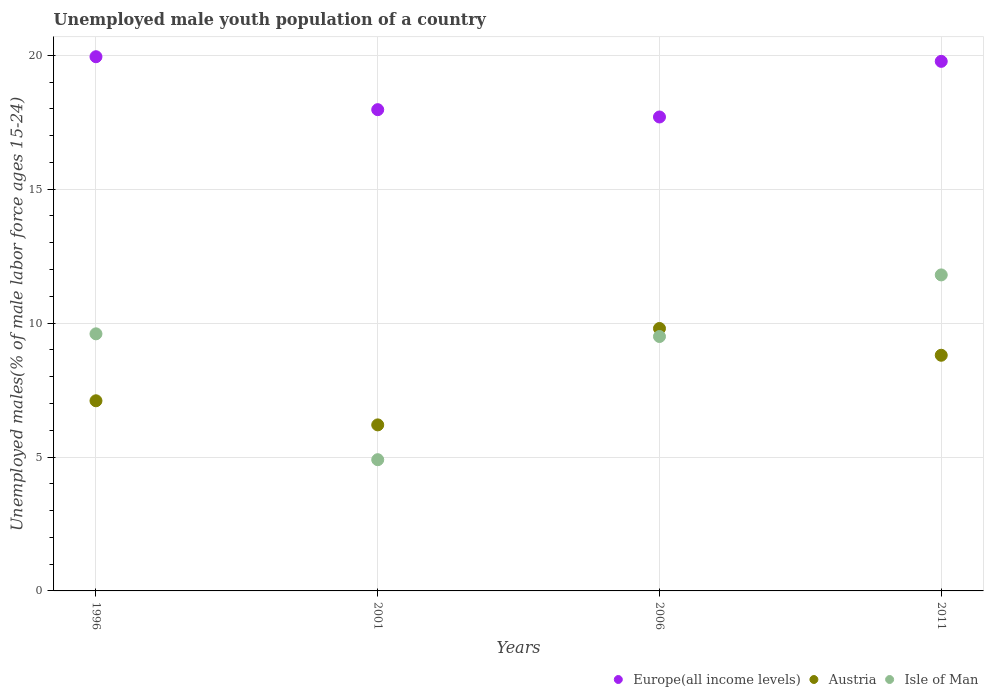How many different coloured dotlines are there?
Keep it short and to the point. 3. Is the number of dotlines equal to the number of legend labels?
Your answer should be very brief. Yes. What is the percentage of unemployed male youth population in Isle of Man in 1996?
Your response must be concise. 9.6. Across all years, what is the maximum percentage of unemployed male youth population in Austria?
Provide a succinct answer. 9.8. Across all years, what is the minimum percentage of unemployed male youth population in Europe(all income levels)?
Keep it short and to the point. 17.7. In which year was the percentage of unemployed male youth population in Isle of Man maximum?
Provide a short and direct response. 2011. In which year was the percentage of unemployed male youth population in Europe(all income levels) minimum?
Your answer should be compact. 2006. What is the total percentage of unemployed male youth population in Austria in the graph?
Make the answer very short. 31.9. What is the difference between the percentage of unemployed male youth population in Isle of Man in 1996 and that in 2001?
Your answer should be very brief. 4.7. What is the difference between the percentage of unemployed male youth population in Isle of Man in 2006 and the percentage of unemployed male youth population in Austria in 2011?
Keep it short and to the point. 0.7. What is the average percentage of unemployed male youth population in Austria per year?
Make the answer very short. 7.98. In the year 1996, what is the difference between the percentage of unemployed male youth population in Isle of Man and percentage of unemployed male youth population in Austria?
Give a very brief answer. 2.5. What is the ratio of the percentage of unemployed male youth population in Austria in 1996 to that in 2006?
Offer a very short reply. 0.72. Is the difference between the percentage of unemployed male youth population in Isle of Man in 1996 and 2006 greater than the difference between the percentage of unemployed male youth population in Austria in 1996 and 2006?
Give a very brief answer. Yes. What is the difference between the highest and the lowest percentage of unemployed male youth population in Austria?
Your answer should be very brief. 3.6. Is it the case that in every year, the sum of the percentage of unemployed male youth population in Isle of Man and percentage of unemployed male youth population in Europe(all income levels)  is greater than the percentage of unemployed male youth population in Austria?
Make the answer very short. Yes. Is the percentage of unemployed male youth population in Isle of Man strictly less than the percentage of unemployed male youth population in Europe(all income levels) over the years?
Provide a short and direct response. Yes. How many dotlines are there?
Your answer should be very brief. 3. How many years are there in the graph?
Provide a short and direct response. 4. Are the values on the major ticks of Y-axis written in scientific E-notation?
Give a very brief answer. No. What is the title of the graph?
Your answer should be compact. Unemployed male youth population of a country. Does "Bosnia and Herzegovina" appear as one of the legend labels in the graph?
Offer a very short reply. No. What is the label or title of the X-axis?
Your answer should be compact. Years. What is the label or title of the Y-axis?
Your answer should be very brief. Unemployed males(% of male labor force ages 15-24). What is the Unemployed males(% of male labor force ages 15-24) of Europe(all income levels) in 1996?
Provide a succinct answer. 19.95. What is the Unemployed males(% of male labor force ages 15-24) in Austria in 1996?
Your answer should be compact. 7.1. What is the Unemployed males(% of male labor force ages 15-24) of Isle of Man in 1996?
Ensure brevity in your answer.  9.6. What is the Unemployed males(% of male labor force ages 15-24) in Europe(all income levels) in 2001?
Make the answer very short. 17.97. What is the Unemployed males(% of male labor force ages 15-24) of Austria in 2001?
Ensure brevity in your answer.  6.2. What is the Unemployed males(% of male labor force ages 15-24) of Isle of Man in 2001?
Give a very brief answer. 4.9. What is the Unemployed males(% of male labor force ages 15-24) of Europe(all income levels) in 2006?
Your answer should be very brief. 17.7. What is the Unemployed males(% of male labor force ages 15-24) of Austria in 2006?
Give a very brief answer. 9.8. What is the Unemployed males(% of male labor force ages 15-24) in Isle of Man in 2006?
Provide a short and direct response. 9.5. What is the Unemployed males(% of male labor force ages 15-24) of Europe(all income levels) in 2011?
Ensure brevity in your answer.  19.77. What is the Unemployed males(% of male labor force ages 15-24) of Austria in 2011?
Keep it short and to the point. 8.8. What is the Unemployed males(% of male labor force ages 15-24) in Isle of Man in 2011?
Your response must be concise. 11.8. Across all years, what is the maximum Unemployed males(% of male labor force ages 15-24) in Europe(all income levels)?
Give a very brief answer. 19.95. Across all years, what is the maximum Unemployed males(% of male labor force ages 15-24) in Austria?
Keep it short and to the point. 9.8. Across all years, what is the maximum Unemployed males(% of male labor force ages 15-24) of Isle of Man?
Ensure brevity in your answer.  11.8. Across all years, what is the minimum Unemployed males(% of male labor force ages 15-24) of Europe(all income levels)?
Your answer should be compact. 17.7. Across all years, what is the minimum Unemployed males(% of male labor force ages 15-24) of Austria?
Your response must be concise. 6.2. Across all years, what is the minimum Unemployed males(% of male labor force ages 15-24) in Isle of Man?
Give a very brief answer. 4.9. What is the total Unemployed males(% of male labor force ages 15-24) of Europe(all income levels) in the graph?
Give a very brief answer. 75.39. What is the total Unemployed males(% of male labor force ages 15-24) of Austria in the graph?
Keep it short and to the point. 31.9. What is the total Unemployed males(% of male labor force ages 15-24) of Isle of Man in the graph?
Provide a short and direct response. 35.8. What is the difference between the Unemployed males(% of male labor force ages 15-24) of Europe(all income levels) in 1996 and that in 2001?
Provide a succinct answer. 1.98. What is the difference between the Unemployed males(% of male labor force ages 15-24) of Isle of Man in 1996 and that in 2001?
Your answer should be very brief. 4.7. What is the difference between the Unemployed males(% of male labor force ages 15-24) of Europe(all income levels) in 1996 and that in 2006?
Give a very brief answer. 2.25. What is the difference between the Unemployed males(% of male labor force ages 15-24) in Isle of Man in 1996 and that in 2006?
Make the answer very short. 0.1. What is the difference between the Unemployed males(% of male labor force ages 15-24) of Europe(all income levels) in 1996 and that in 2011?
Offer a very short reply. 0.17. What is the difference between the Unemployed males(% of male labor force ages 15-24) of Austria in 1996 and that in 2011?
Your response must be concise. -1.7. What is the difference between the Unemployed males(% of male labor force ages 15-24) in Europe(all income levels) in 2001 and that in 2006?
Your answer should be very brief. 0.27. What is the difference between the Unemployed males(% of male labor force ages 15-24) in Austria in 2001 and that in 2006?
Make the answer very short. -3.6. What is the difference between the Unemployed males(% of male labor force ages 15-24) in Isle of Man in 2001 and that in 2006?
Your response must be concise. -4.6. What is the difference between the Unemployed males(% of male labor force ages 15-24) of Europe(all income levels) in 2001 and that in 2011?
Offer a very short reply. -1.8. What is the difference between the Unemployed males(% of male labor force ages 15-24) of Austria in 2001 and that in 2011?
Offer a terse response. -2.6. What is the difference between the Unemployed males(% of male labor force ages 15-24) of Isle of Man in 2001 and that in 2011?
Give a very brief answer. -6.9. What is the difference between the Unemployed males(% of male labor force ages 15-24) of Europe(all income levels) in 2006 and that in 2011?
Ensure brevity in your answer.  -2.08. What is the difference between the Unemployed males(% of male labor force ages 15-24) of Austria in 2006 and that in 2011?
Make the answer very short. 1. What is the difference between the Unemployed males(% of male labor force ages 15-24) in Europe(all income levels) in 1996 and the Unemployed males(% of male labor force ages 15-24) in Austria in 2001?
Give a very brief answer. 13.75. What is the difference between the Unemployed males(% of male labor force ages 15-24) of Europe(all income levels) in 1996 and the Unemployed males(% of male labor force ages 15-24) of Isle of Man in 2001?
Provide a succinct answer. 15.05. What is the difference between the Unemployed males(% of male labor force ages 15-24) of Austria in 1996 and the Unemployed males(% of male labor force ages 15-24) of Isle of Man in 2001?
Offer a terse response. 2.2. What is the difference between the Unemployed males(% of male labor force ages 15-24) in Europe(all income levels) in 1996 and the Unemployed males(% of male labor force ages 15-24) in Austria in 2006?
Keep it short and to the point. 10.15. What is the difference between the Unemployed males(% of male labor force ages 15-24) of Europe(all income levels) in 1996 and the Unemployed males(% of male labor force ages 15-24) of Isle of Man in 2006?
Ensure brevity in your answer.  10.45. What is the difference between the Unemployed males(% of male labor force ages 15-24) in Austria in 1996 and the Unemployed males(% of male labor force ages 15-24) in Isle of Man in 2006?
Keep it short and to the point. -2.4. What is the difference between the Unemployed males(% of male labor force ages 15-24) of Europe(all income levels) in 1996 and the Unemployed males(% of male labor force ages 15-24) of Austria in 2011?
Your answer should be compact. 11.15. What is the difference between the Unemployed males(% of male labor force ages 15-24) of Europe(all income levels) in 1996 and the Unemployed males(% of male labor force ages 15-24) of Isle of Man in 2011?
Make the answer very short. 8.15. What is the difference between the Unemployed males(% of male labor force ages 15-24) of Europe(all income levels) in 2001 and the Unemployed males(% of male labor force ages 15-24) of Austria in 2006?
Make the answer very short. 8.17. What is the difference between the Unemployed males(% of male labor force ages 15-24) of Europe(all income levels) in 2001 and the Unemployed males(% of male labor force ages 15-24) of Isle of Man in 2006?
Give a very brief answer. 8.47. What is the difference between the Unemployed males(% of male labor force ages 15-24) of Europe(all income levels) in 2001 and the Unemployed males(% of male labor force ages 15-24) of Austria in 2011?
Your response must be concise. 9.17. What is the difference between the Unemployed males(% of male labor force ages 15-24) of Europe(all income levels) in 2001 and the Unemployed males(% of male labor force ages 15-24) of Isle of Man in 2011?
Make the answer very short. 6.17. What is the difference between the Unemployed males(% of male labor force ages 15-24) of Austria in 2001 and the Unemployed males(% of male labor force ages 15-24) of Isle of Man in 2011?
Your response must be concise. -5.6. What is the difference between the Unemployed males(% of male labor force ages 15-24) of Europe(all income levels) in 2006 and the Unemployed males(% of male labor force ages 15-24) of Austria in 2011?
Offer a very short reply. 8.9. What is the difference between the Unemployed males(% of male labor force ages 15-24) of Europe(all income levels) in 2006 and the Unemployed males(% of male labor force ages 15-24) of Isle of Man in 2011?
Provide a succinct answer. 5.9. What is the average Unemployed males(% of male labor force ages 15-24) of Europe(all income levels) per year?
Provide a succinct answer. 18.85. What is the average Unemployed males(% of male labor force ages 15-24) in Austria per year?
Your answer should be compact. 7.97. What is the average Unemployed males(% of male labor force ages 15-24) of Isle of Man per year?
Offer a terse response. 8.95. In the year 1996, what is the difference between the Unemployed males(% of male labor force ages 15-24) of Europe(all income levels) and Unemployed males(% of male labor force ages 15-24) of Austria?
Ensure brevity in your answer.  12.85. In the year 1996, what is the difference between the Unemployed males(% of male labor force ages 15-24) of Europe(all income levels) and Unemployed males(% of male labor force ages 15-24) of Isle of Man?
Keep it short and to the point. 10.35. In the year 2001, what is the difference between the Unemployed males(% of male labor force ages 15-24) of Europe(all income levels) and Unemployed males(% of male labor force ages 15-24) of Austria?
Ensure brevity in your answer.  11.77. In the year 2001, what is the difference between the Unemployed males(% of male labor force ages 15-24) in Europe(all income levels) and Unemployed males(% of male labor force ages 15-24) in Isle of Man?
Provide a short and direct response. 13.07. In the year 2006, what is the difference between the Unemployed males(% of male labor force ages 15-24) in Europe(all income levels) and Unemployed males(% of male labor force ages 15-24) in Austria?
Offer a very short reply. 7.9. In the year 2006, what is the difference between the Unemployed males(% of male labor force ages 15-24) of Europe(all income levels) and Unemployed males(% of male labor force ages 15-24) of Isle of Man?
Offer a terse response. 8.2. In the year 2006, what is the difference between the Unemployed males(% of male labor force ages 15-24) in Austria and Unemployed males(% of male labor force ages 15-24) in Isle of Man?
Offer a terse response. 0.3. In the year 2011, what is the difference between the Unemployed males(% of male labor force ages 15-24) of Europe(all income levels) and Unemployed males(% of male labor force ages 15-24) of Austria?
Provide a short and direct response. 10.97. In the year 2011, what is the difference between the Unemployed males(% of male labor force ages 15-24) of Europe(all income levels) and Unemployed males(% of male labor force ages 15-24) of Isle of Man?
Your answer should be compact. 7.97. What is the ratio of the Unemployed males(% of male labor force ages 15-24) of Europe(all income levels) in 1996 to that in 2001?
Offer a terse response. 1.11. What is the ratio of the Unemployed males(% of male labor force ages 15-24) of Austria in 1996 to that in 2001?
Offer a very short reply. 1.15. What is the ratio of the Unemployed males(% of male labor force ages 15-24) of Isle of Man in 1996 to that in 2001?
Make the answer very short. 1.96. What is the ratio of the Unemployed males(% of male labor force ages 15-24) in Europe(all income levels) in 1996 to that in 2006?
Offer a very short reply. 1.13. What is the ratio of the Unemployed males(% of male labor force ages 15-24) in Austria in 1996 to that in 2006?
Your response must be concise. 0.72. What is the ratio of the Unemployed males(% of male labor force ages 15-24) in Isle of Man in 1996 to that in 2006?
Provide a succinct answer. 1.01. What is the ratio of the Unemployed males(% of male labor force ages 15-24) in Europe(all income levels) in 1996 to that in 2011?
Your answer should be very brief. 1.01. What is the ratio of the Unemployed males(% of male labor force ages 15-24) in Austria in 1996 to that in 2011?
Your answer should be very brief. 0.81. What is the ratio of the Unemployed males(% of male labor force ages 15-24) in Isle of Man in 1996 to that in 2011?
Ensure brevity in your answer.  0.81. What is the ratio of the Unemployed males(% of male labor force ages 15-24) of Europe(all income levels) in 2001 to that in 2006?
Keep it short and to the point. 1.02. What is the ratio of the Unemployed males(% of male labor force ages 15-24) of Austria in 2001 to that in 2006?
Your answer should be compact. 0.63. What is the ratio of the Unemployed males(% of male labor force ages 15-24) of Isle of Man in 2001 to that in 2006?
Your answer should be compact. 0.52. What is the ratio of the Unemployed males(% of male labor force ages 15-24) in Europe(all income levels) in 2001 to that in 2011?
Make the answer very short. 0.91. What is the ratio of the Unemployed males(% of male labor force ages 15-24) of Austria in 2001 to that in 2011?
Offer a terse response. 0.7. What is the ratio of the Unemployed males(% of male labor force ages 15-24) in Isle of Man in 2001 to that in 2011?
Give a very brief answer. 0.42. What is the ratio of the Unemployed males(% of male labor force ages 15-24) in Europe(all income levels) in 2006 to that in 2011?
Your answer should be compact. 0.9. What is the ratio of the Unemployed males(% of male labor force ages 15-24) of Austria in 2006 to that in 2011?
Give a very brief answer. 1.11. What is the ratio of the Unemployed males(% of male labor force ages 15-24) of Isle of Man in 2006 to that in 2011?
Provide a succinct answer. 0.81. What is the difference between the highest and the second highest Unemployed males(% of male labor force ages 15-24) of Europe(all income levels)?
Provide a short and direct response. 0.17. What is the difference between the highest and the second highest Unemployed males(% of male labor force ages 15-24) in Austria?
Your answer should be very brief. 1. What is the difference between the highest and the second highest Unemployed males(% of male labor force ages 15-24) of Isle of Man?
Your answer should be very brief. 2.2. What is the difference between the highest and the lowest Unemployed males(% of male labor force ages 15-24) in Europe(all income levels)?
Offer a very short reply. 2.25. What is the difference between the highest and the lowest Unemployed males(% of male labor force ages 15-24) in Austria?
Keep it short and to the point. 3.6. 